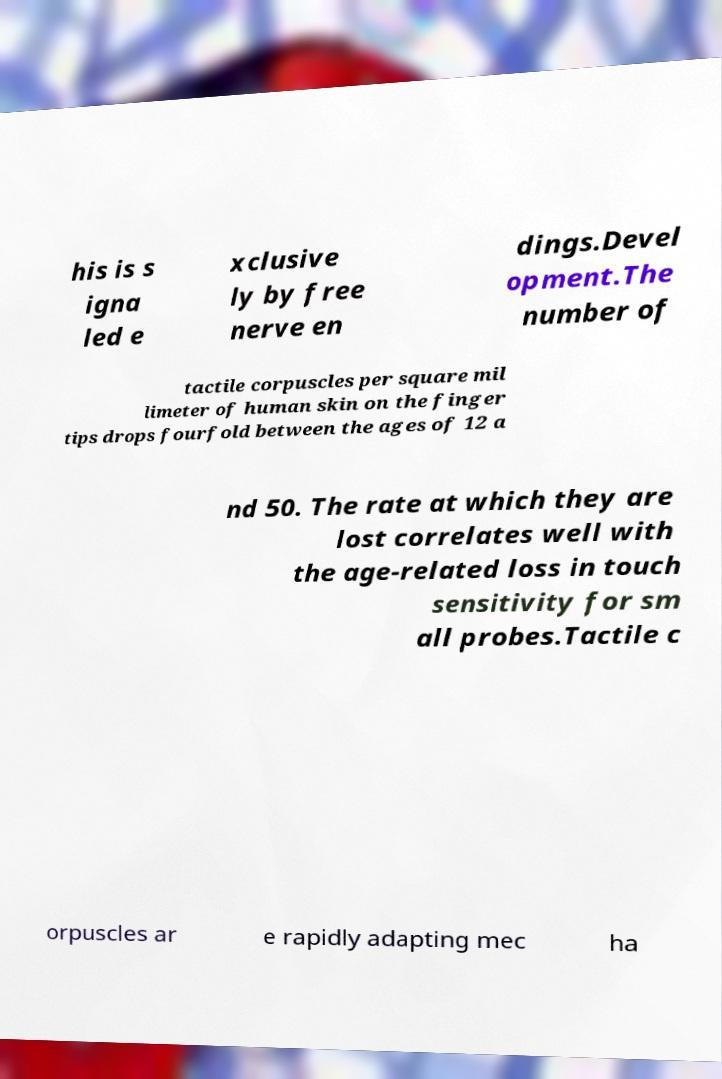Can you accurately transcribe the text from the provided image for me? his is s igna led e xclusive ly by free nerve en dings.Devel opment.The number of tactile corpuscles per square mil limeter of human skin on the finger tips drops fourfold between the ages of 12 a nd 50. The rate at which they are lost correlates well with the age-related loss in touch sensitivity for sm all probes.Tactile c orpuscles ar e rapidly adapting mec ha 